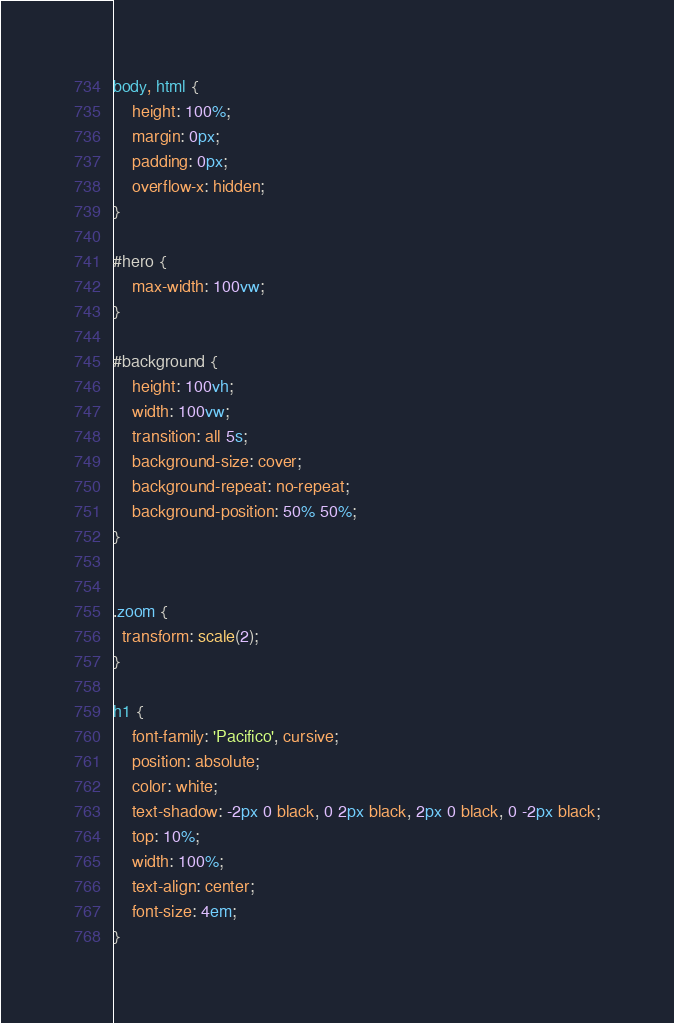Convert code to text. <code><loc_0><loc_0><loc_500><loc_500><_CSS_>body, html {
    height: 100%;
    margin: 0px;
    padding: 0px;
    overflow-x: hidden;
}

#hero {
    max-width: 100vw;
}

#background {
    height: 100vh;
    width: 100vw;
    transition: all 5s;
    background-size: cover;
    background-repeat: no-repeat;
    background-position: 50% 50%;
}


.zoom {
  transform: scale(2);
}

h1 {
    font-family: 'Pacifico', cursive;
    position: absolute;
    color: white;
    text-shadow: -2px 0 black, 0 2px black, 2px 0 black, 0 -2px black;
    top: 10%;
    width: 100%;
    text-align: center;
    font-size: 4em;
}</code> 